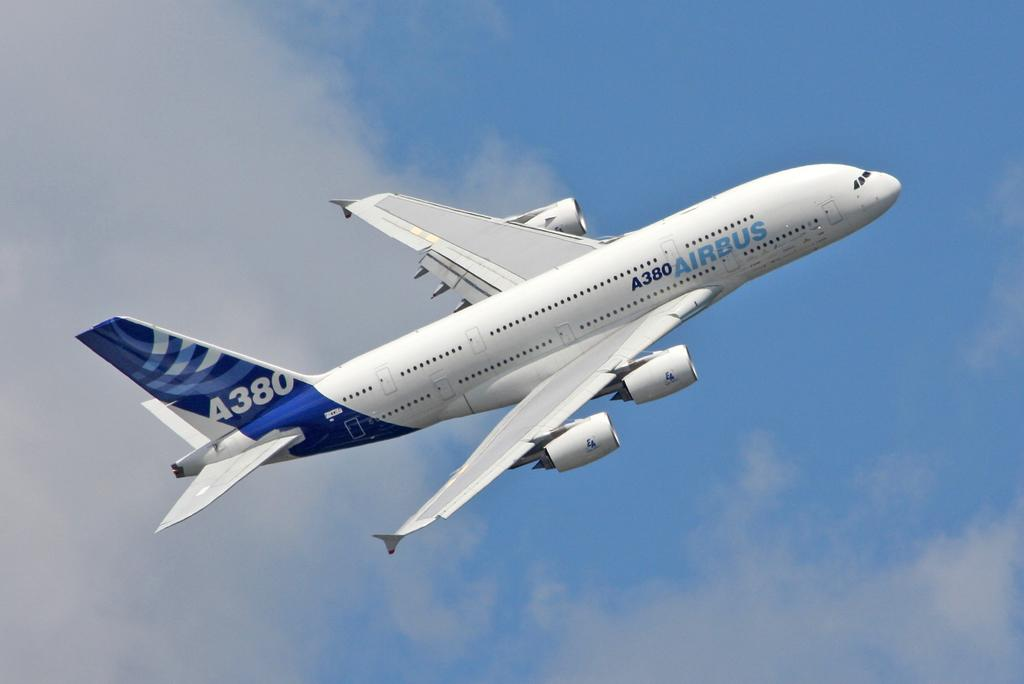<image>
Give a short and clear explanation of the subsequent image. An Airbus A380 is taking off into the sky. 